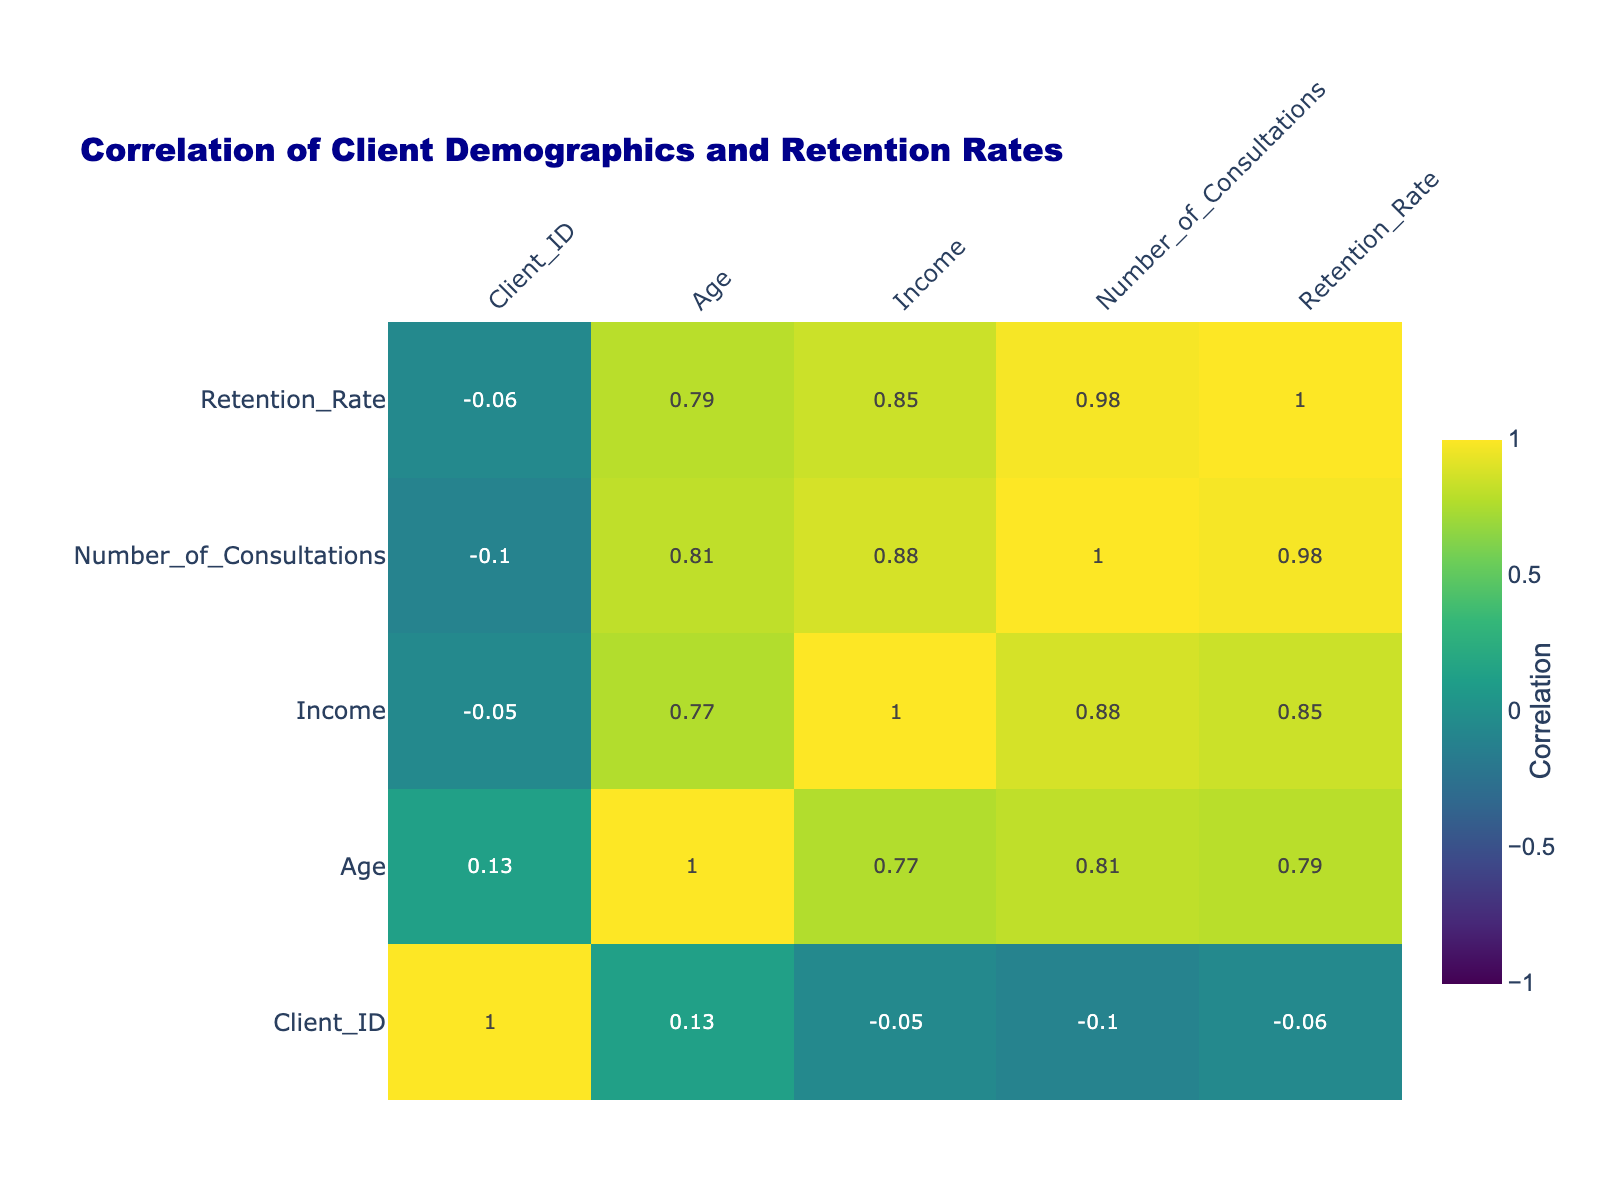What is the retention rate for clients with a Doctorate education level? In the table, we find that there are two clients with a Doctorate education level (Client_ID 4 and Client_ID 8). The retention rates for these clients are 0.85 and 0.90 respectively. To find the answer, we refer to these values directly.
Answer: 0.85 and 0.90 What is the average income for clients who are Married? We first identify all clients who are Married (Client_ID 1, 4, 5, 10). Their incomes are 75000, 120000, 50000, and 85000. We then add these incomes (75000 + 120000 + 50000 + 85000 = 330000) and divide by the number of Married clients (4) to find the average: 330000 / 4 = 82500.
Answer: 82500 Are clients with higher education levels generally more likely to have higher retention rates? By examining the correlation values in the table, we would see a positive correlation between Education_Level and Retention_Rate, indicating that clients with higher education levels tend to have higher retention rates. This means the fact is true.
Answer: Yes Which age group has the highest average retention rate? We categorize clients by age: 20-30 (Clients 3, 7, 9), 31-40 (Clients 1, 5, 6), 41-50 (Clients 2, 10), and 51-60 (Clients 4, 8). We then calculate the average retention rate for each age range: 20-30 (0.65 + 0.68 + 0.55)/3 = 0.613, 31-40 (0.80 + 0.60 + 0.75)/3 = 0.717, 41-50 (0.70 + 0.78)/2 = 0.740, and 51-60 (0.85 + 0.90)/2 = 0.875. Therefore, the highest average retention rate is in the 51-60 age group.
Answer: 51-60 Is there a positive correlation between the Number_of_Consultations and Retention_Rate? We look at the correlation value between these two variables in the table. A positive correlation value would indicate that as the number of consultations increases, the retention rate also increases. This indicates a true correlation.
Answer: Yes What is the retention rate difference between clients who are Single and those who are Married? We first identify the clients in each marital status category. The retention rates for Single clients (Client_ID 2 and 9) are 0.70 and 0.55 respectively, giving an average of (0.70 + 0.55)/2 = 0.625. For Married clients (Client_ID 1, 4, 5, and 10), the rates are 0.80, 0.85, 0.60, 0.78, giving an average of (0.80 + 0.85 + 0.60 + 0.78)/4 = 0.7575. The difference is 0.7575 - 0.625 = 0.1325.
Answer: 0.1325 Which Client_ID corresponds to the oldest client, and what is their retention rate? We identify the ages of each client: Client_ID 1 (34), 2 (45), 3 (29), 4 (51), 5 (38), 6 (42), 7 (30), 8 (55), 9 (27), 10 (48). The oldest is Client_ID 8 at an age of 55, with a retention rate of 0.90.
Answer: Client_ID 8, 0.90 How many consultations did the client with the lowest retention rate have? Looking at the retention rates, Client_ID 9 has the lowest retention rate at 0.55. Referring to the table, this client had 3 consultations.
Answer: 3 